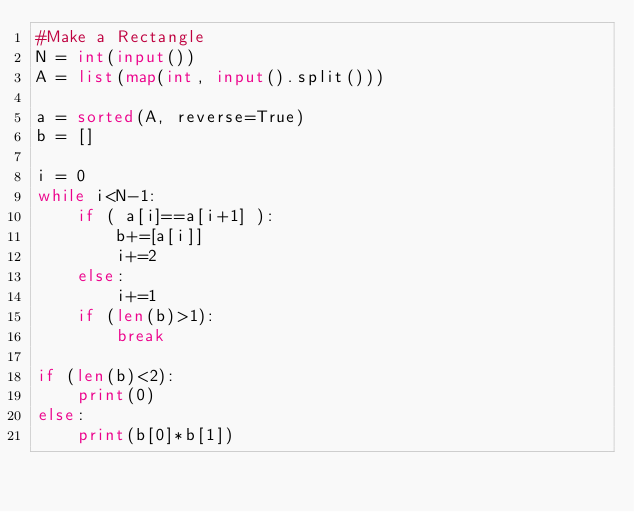Convert code to text. <code><loc_0><loc_0><loc_500><loc_500><_Python_>#Make a Rectangle
N = int(input())
A = list(map(int, input().split()))

a = sorted(A, reverse=True)
b = []

i = 0
while i<N-1:
    if ( a[i]==a[i+1] ):
        b+=[a[i]]
        i+=2
    else:
        i+=1
    if (len(b)>1):
        break

if (len(b)<2):
    print(0)
else:
    print(b[0]*b[1])</code> 